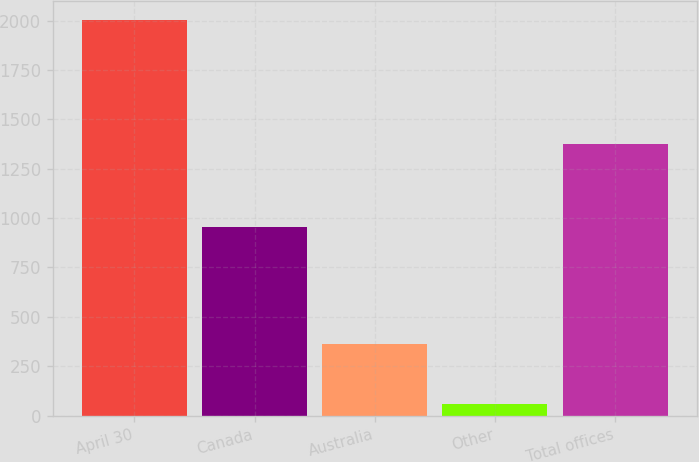<chart> <loc_0><loc_0><loc_500><loc_500><bar_chart><fcel>April 30<fcel>Canada<fcel>Australia<fcel>Other<fcel>Total offices<nl><fcel>2002<fcel>955<fcel>362<fcel>59<fcel>1376<nl></chart> 